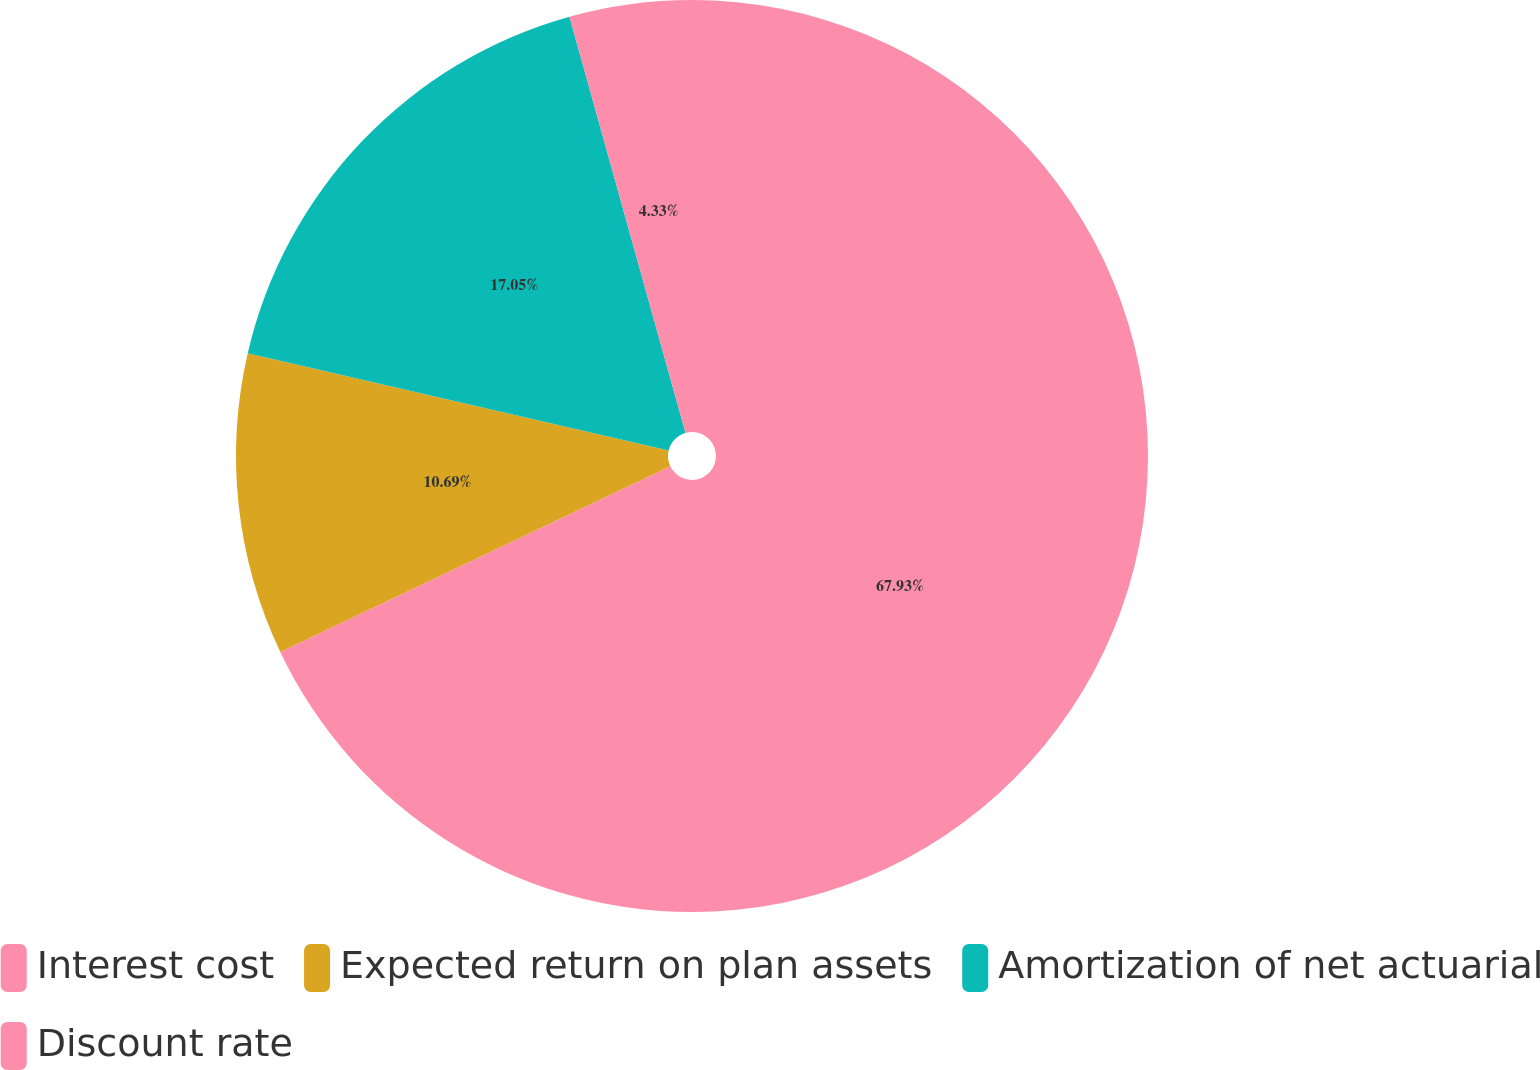<chart> <loc_0><loc_0><loc_500><loc_500><pie_chart><fcel>Interest cost<fcel>Expected return on plan assets<fcel>Amortization of net actuarial<fcel>Discount rate<nl><fcel>67.93%<fcel>10.69%<fcel>17.05%<fcel>4.33%<nl></chart> 